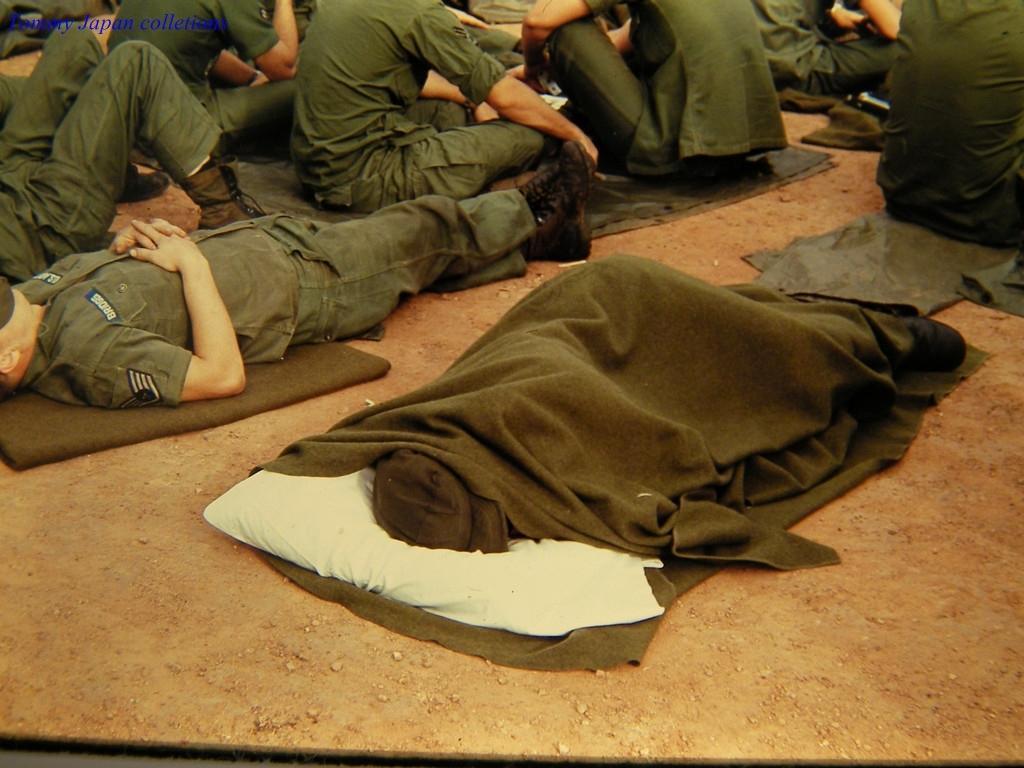In one or two sentences, can you explain what this image depicts? In this image I can see few people are sitting and few people are sleeping on the ground. I can see the blanket and they are wearing green color dresses. 